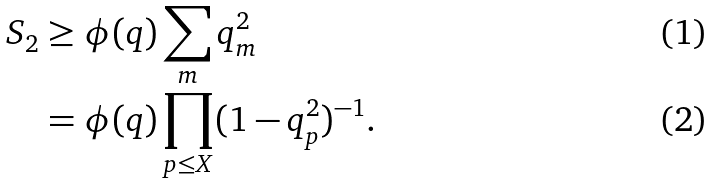Convert formula to latex. <formula><loc_0><loc_0><loc_500><loc_500>S _ { 2 } & \geq \phi ( q ) \sum _ { m } q _ { m } ^ { 2 } \\ & = \phi ( q ) \prod _ { p \leq X } ( 1 - q _ { p } ^ { 2 } ) ^ { - 1 } .</formula> 